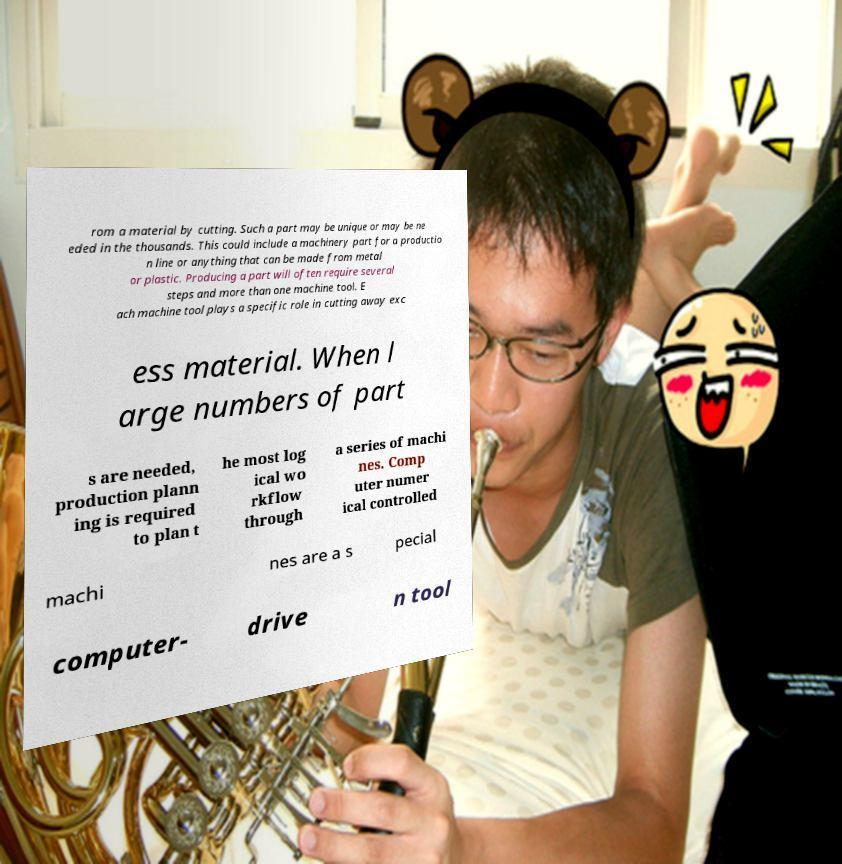There's text embedded in this image that I need extracted. Can you transcribe it verbatim? rom a material by cutting. Such a part may be unique or may be ne eded in the thousands. This could include a machinery part for a productio n line or anything that can be made from metal or plastic. Producing a part will often require several steps and more than one machine tool. E ach machine tool plays a specific role in cutting away exc ess material. When l arge numbers of part s are needed, production plann ing is required to plan t he most log ical wo rkflow through a series of machi nes. Comp uter numer ical controlled machi nes are a s pecial computer- drive n tool 